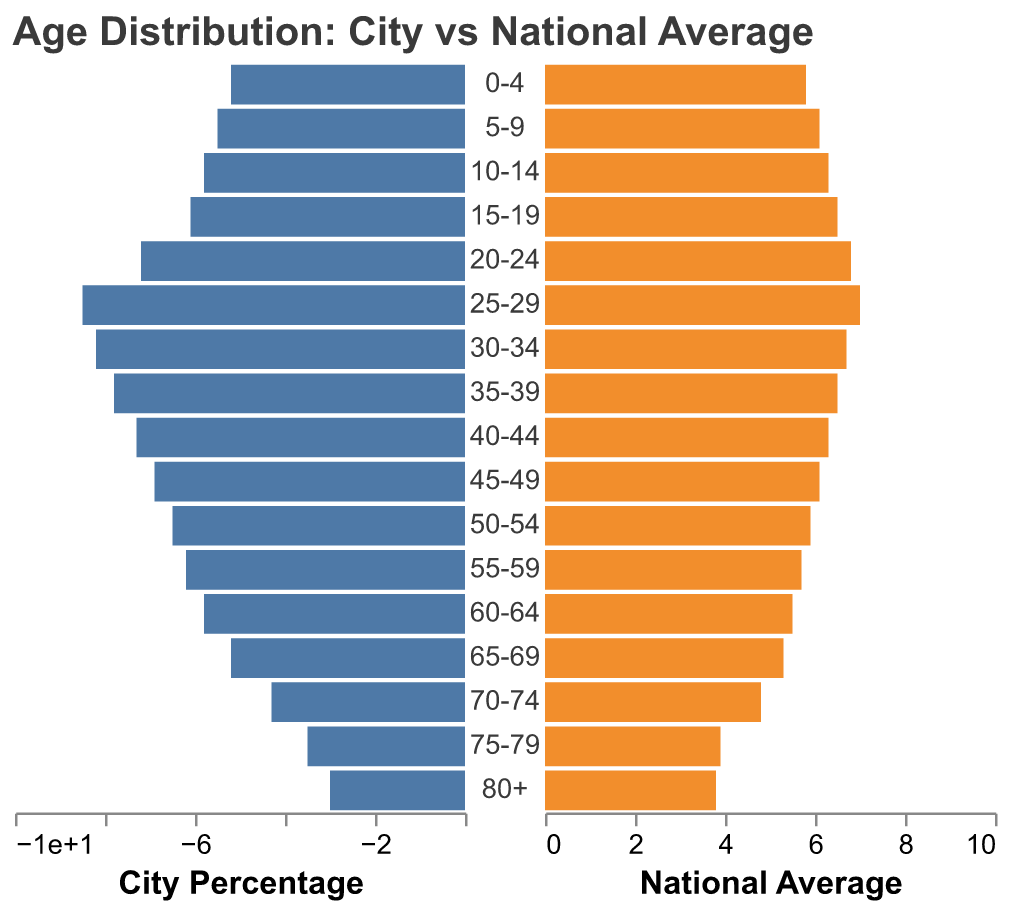What is the age group with the highest city percentage? The highest city percentage is listed under the age group 25-29, which shows a city percentage of 8.5%.
Answer: 25-29 Which age group has a higher national average than city percentage? By comparing each age group, we can see that the age groups 0-4, 5-9, 10-14, 15-19, 70-74, 75-79, and 80+ have higher national averages than city percentages.
Answer: 0-4, 5-9, 10-14, 15-19, 70-74, 75-79, 80+ What is the percentage difference between the city and national average for the 20-24 age group? The city percentage for the 20-24 age group is 7.2%, and the national average is 6.8%. The difference is 7.2 - 6.8 = 0.4%.
Answer: 0.4% Which age group's city percentage is closest to the national average? By comparing each age group's city percentage and national average, the 65-69 age group has a city percentage of 5.2% and a national average of 5.3%, resulting in a very close comparison.
Answer: 65-69 What is the total percentage for city residents aged 60 and over? We sum the percentages for the age groups 60-64 (5.8), 65-69 (5.2), 70-74 (4.3), 75-79 (3.5), and 80+ (3.0) for the city residents. The total is 5.8 + 5.2 + 4.3 + 3.5 + 3.0 = 21.8%.
Answer: 21.8% Is the city percentage for the age group 30-34 greater or smaller than the national average? For the age group 30-34, the city percentage is 8.2% compared to the national average of 6.7%. Therefore, the city percentage is greater.
Answer: Greater How many age groups have city percentages above 7%? The age groups with city percentages above 7% are 20-24 (7.2%), 25-29 (8.5%), 30-34 (8.2%), and 35-39 (7.8%). So there are 4 age groups.
Answer: 4 What is the age group with the smallest city percentage? The smallest city percentage is listed under the age group 80+, which shows a city percentage of 3.0%.
Answer: 80+ 